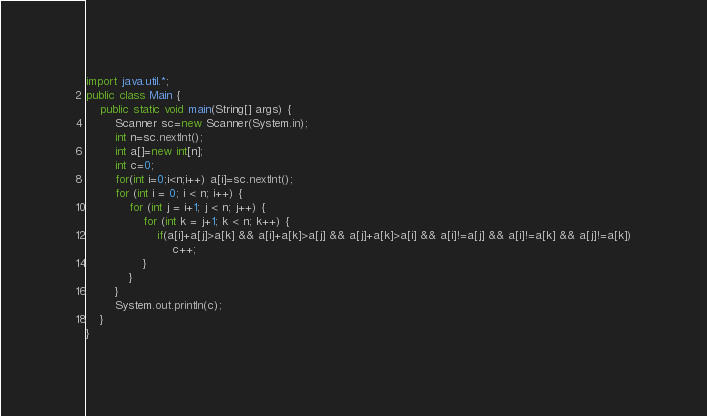Convert code to text. <code><loc_0><loc_0><loc_500><loc_500><_Java_>import java.util.*;
public class Main {
	public static void main(String[] args) {
		Scanner sc=new Scanner(System.in);
		int n=sc.nextInt();
		int a[]=new int[n];
		int c=0;
		for(int i=0;i<n;i++) a[i]=sc.nextInt();
		for (int i = 0; i < n; i++) {
			for (int j = i+1; j < n; j++) {
				for (int k = j+1; k < n; k++) {
					if(a[i]+a[j]>a[k] && a[i]+a[k]>a[j] && a[j]+a[k]>a[i] && a[i]!=a[j] && a[i]!=a[k] && a[j]!=a[k])
						c++;
				}
			}
		}
		System.out.println(c);
	}
}</code> 